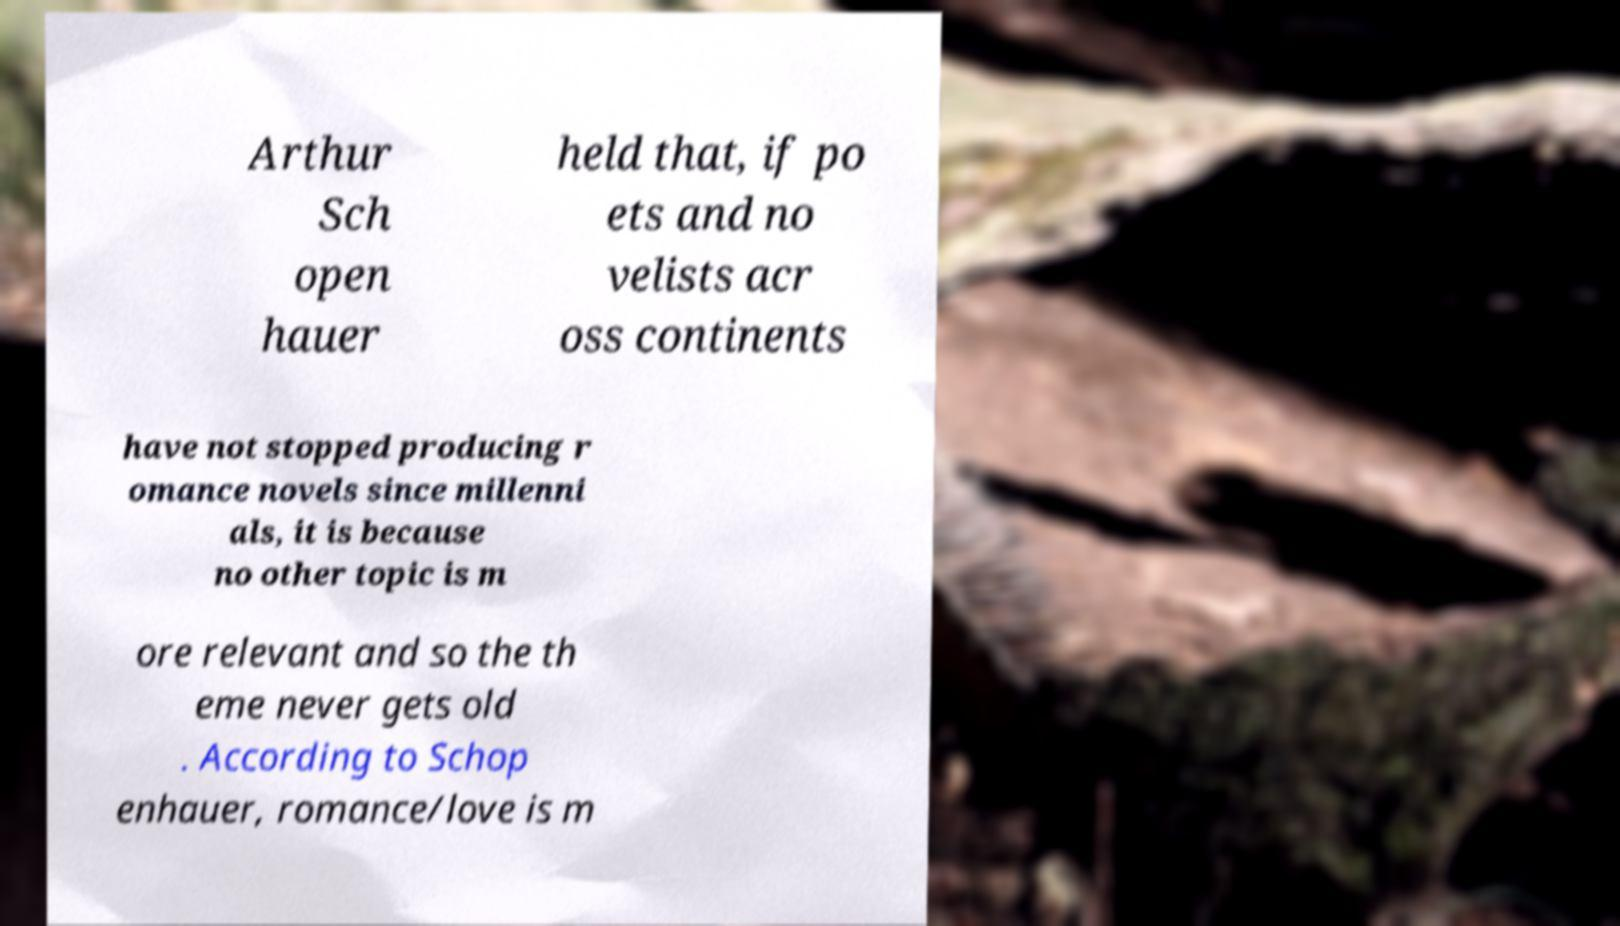Can you accurately transcribe the text from the provided image for me? Arthur Sch open hauer held that, if po ets and no velists acr oss continents have not stopped producing r omance novels since millenni als, it is because no other topic is m ore relevant and so the th eme never gets old . According to Schop enhauer, romance/love is m 